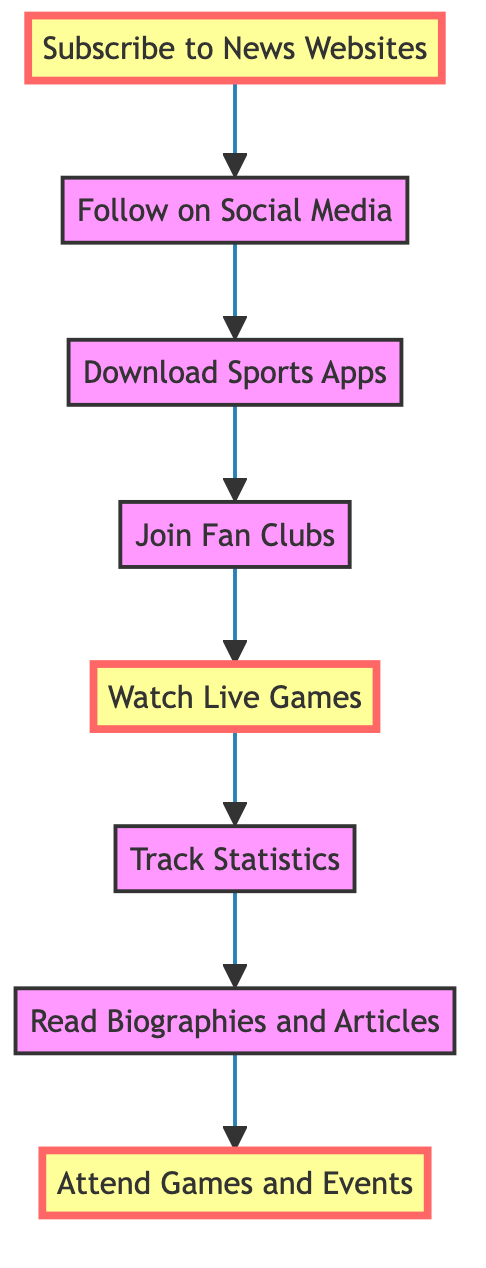What is the first step in following Tom Brady's career? The first step is denoted by the topmost node in the diagram, which is "Subscribe to News Websites."
Answer: Subscribe to News Websites How many total steps are there in the diagram? To determine the total number of steps, we can count the nodes in the diagram. There are eight nodes listed in the flow chart, each representing a step.
Answer: Eight What is the last step before "Attend Games and Events"? The node just before "Attend Games and Events" is "Read Biographies and Articles," indicating it is the step preceding attendance at games and events.
Answer: Read Biographies and Articles What is the relationship between "Download Sports Apps" and "Join Fan Clubs"? "Download Sports Apps" leads to "Join Fan Clubs," indicating that after downloading the apps, the next step is to join fan clubs.
Answer: Leads to Which step involves interacting with Tom Brady on social media? The step that specifically mentions interaction on social media is "Follow on Social Media." This step highlights platforms where fans can connect with Brady directly.
Answer: Follow on Social Media If someone wants real-time notifications about Tom Brady's updates, which step should they focus on? The step focused on real-time notifications is "Download Sports Apps," where it specifically mentions receiving updates through applications.
Answer: Download Sports Apps What color highlights the steps "Subscribe to News Websites," "Watch Live Games," and "Attend Games and Events"? The highlighted steps are colored in a distinct shade, emphasizing their importance in the flow. The color specified for these highlighted steps is yellow.
Answer: Yellow Which step would you take if you want to read in-depth about Tom Brady's life and career? This inquiry relates to a step specifically aimed at gaining deeper insights through reading. The correct step is "Read Biographies and Articles."
Answer: Read Biographies and Articles 